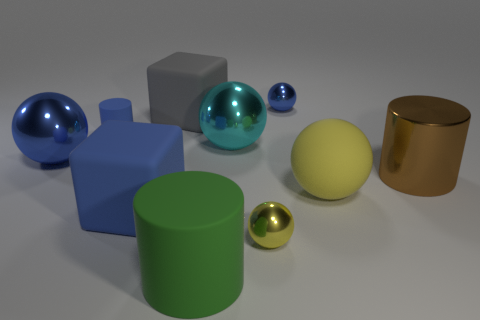Subtract all big metal cylinders. How many cylinders are left? 2 Subtract 2 cubes. How many cubes are left? 0 Subtract all blue blocks. How many blocks are left? 1 Subtract all blocks. How many objects are left? 8 Subtract all red cylinders. Subtract all brown blocks. How many cylinders are left? 3 Subtract all gray cylinders. How many purple balls are left? 0 Subtract all large green things. Subtract all large blue cubes. How many objects are left? 8 Add 2 brown metal cylinders. How many brown metal cylinders are left? 3 Add 2 gray rubber objects. How many gray rubber objects exist? 3 Subtract 0 cyan cubes. How many objects are left? 10 